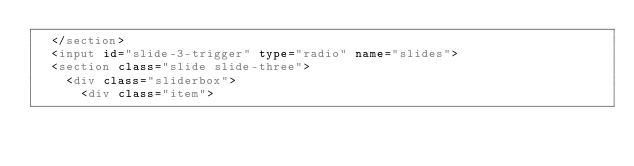Convert code to text. <code><loc_0><loc_0><loc_500><loc_500><_HTML_>  </section>
  <input id="slide-3-trigger" type="radio" name="slides">
  <section class="slide slide-three">
    <div class="sliderbox">
      <div class="item"></code> 